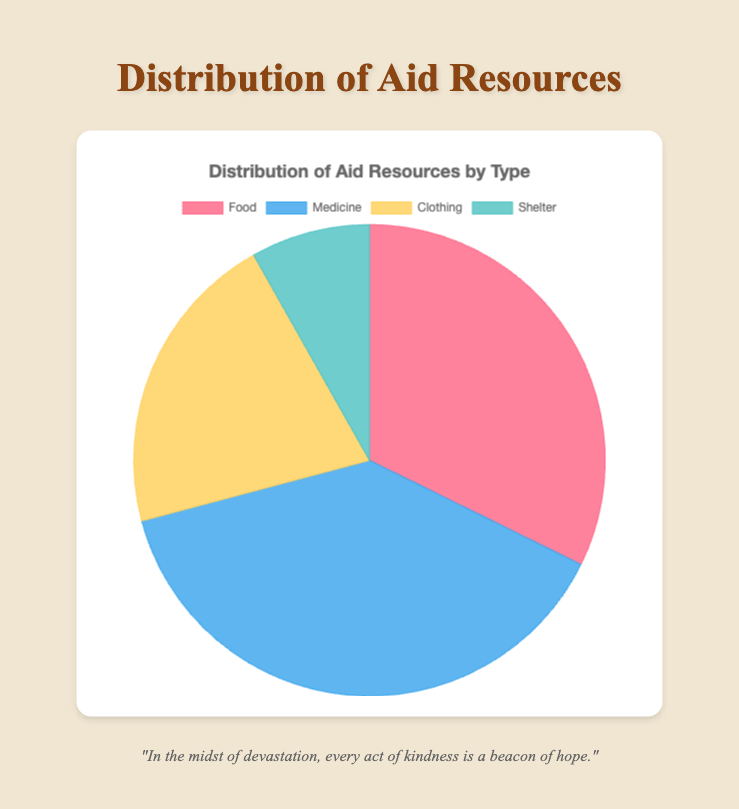What is the percentage of aid resources dedicated to Food? The total amount of aid is the sum of all categories: 7700 (Food) + 9200 (Medicine) + 5000 (Clothing) + 1950 (Shelter) = 23850. The percentage for Food is calculated as (7700 / 23850) * 100.
Answer: 32.3% Which aid resource category has the largest portion? Comparing the values, Food is 7700, Medicine is 9200, Clothing is 5000, and Shelter is 1950. Medicine has the highest value among them.
Answer: Medicine How much more aid is given in Food compared to Shelter? Food has 7700 units and Shelter has 1950 units. The difference is 7700 - 1950.
Answer: 5750 units What is the combined percentage of Medicine and Food? The total aid amount is 23850. The combined value for Medicine and Food is 9200 + 7700 = 16900. The percentage is (16900 / 23850) * 100.
Answer: 70.9% Rank the aid resource categories from highest to lowest distribution. First order the values: Medicine (9200), Food (7700), Clothing (5000), and Shelter (1950). The order from highest to lowest is Medicine, Food, Clothing, Shelter.
Answer: Medicine, Food, Clothing, Shelter What is the average value of aid resources per category? The total aid amount is 23850 and there are 4 categories. The average is 23850 / 4.
Answer: 5962.5 units By how much does the aid for Clothing exceed that for Shelter? Clothing has 5000 units and Shelter has 1950 units. The difference is 5000 - 1950.
Answer: 3050 units Which category has roughly half the distribution value of Medicine? Medicine has 9200 units. Half of this value is 9200 / 2 = 4600. Comparing this to other categories, Clothing has 5000 units, which is closest to 4600.
Answer: Clothing Describe the color used to represent the Medicine category in the pie chart. The Medicine category is represented by a blue color in the pie chart.
Answer: Blue In terms of distribution, how does the aid categorized as Shelter compare with the rest combined? The total amount for all other categories combined is 7700 (Food) + 9200 (Medicine) + 5000 (Clothing) = 21900. Shelter is 1950. Comparing these, Shelter is much less.
Answer: Less 